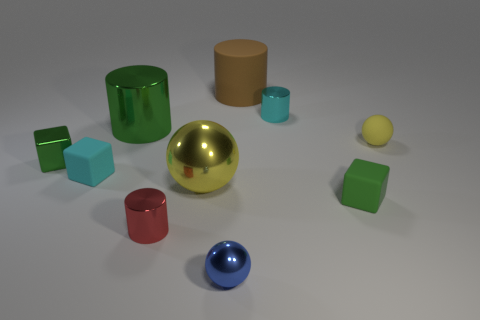Is there a red matte block that has the same size as the yellow matte object?
Your answer should be compact. No. What material is the tiny green thing that is right of the small cyan object that is on the right side of the tiny cyan rubber cube?
Give a very brief answer. Rubber. How many things are the same color as the large matte cylinder?
Provide a short and direct response. 0. There is a big thing that is the same material as the green cylinder; what is its shape?
Your answer should be compact. Sphere. What is the size of the cyan object that is to the right of the large brown cylinder?
Your response must be concise. Small. Is the number of large yellow metallic objects that are behind the green shiny cube the same as the number of green cylinders that are right of the big rubber object?
Your response must be concise. Yes. There is a small matte object on the left side of the small cylinder behind the cyan object in front of the small cyan cylinder; what color is it?
Ensure brevity in your answer.  Cyan. What number of shiny cylinders are both to the left of the cyan cylinder and behind the small yellow sphere?
Your answer should be very brief. 1. There is a rubber object that is in front of the cyan cube; is it the same color as the tiny matte cube that is left of the tiny blue metallic object?
Give a very brief answer. No. Is there anything else that has the same material as the large green object?
Offer a very short reply. Yes. 